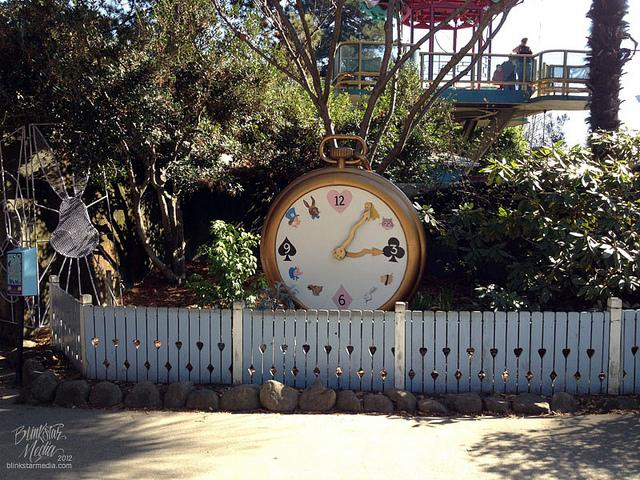This area is based on which author's works? Please explain your reasoning. lewis carroll. Lewis carroll wrote through the looking glass. 